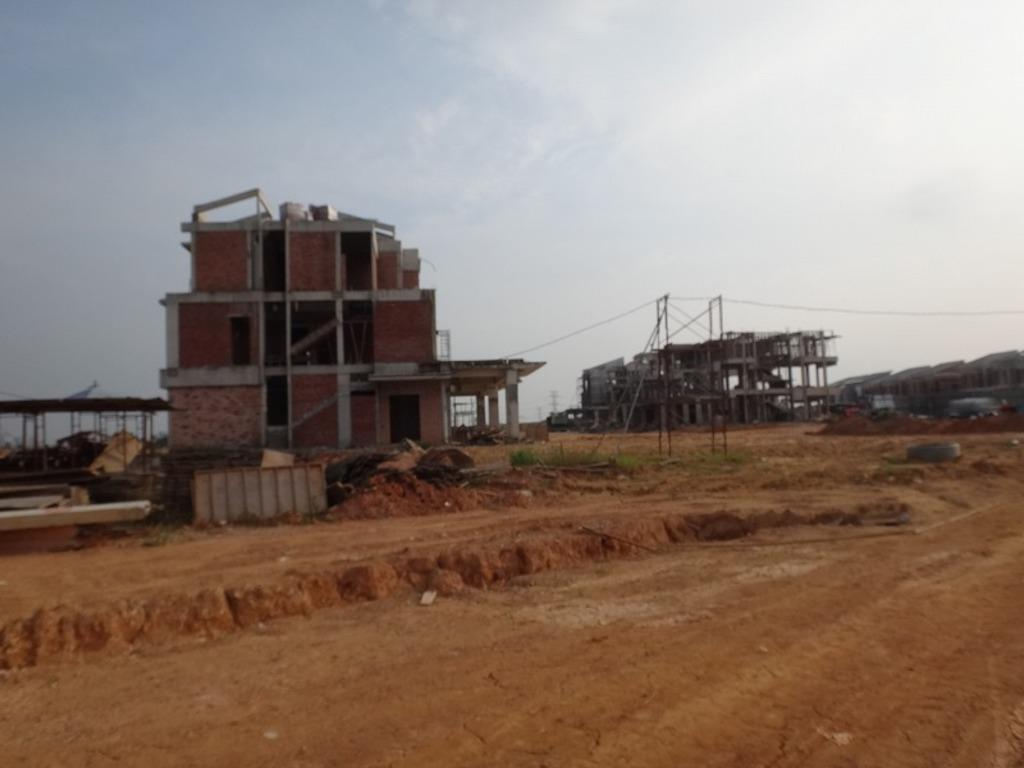What is the main subject of the image? The main subject of the image is under construction buildings. What else can be seen in the image besides the buildings? There are vehicles, trees, grass, poles, cables, a road, and clouds in the sky visible in the image. Can you describe the vehicles in the image? The vehicles in the image are not specified, but they are present. What type of vegetation is visible in the image? Trees and grass are visible in the image. What are the poles and cables used for in the image? The poles and cables are likely used for electrical or communication purposes. What is the condition of the sky in the image? The sky in the image has clouds visible. What type of leather is being used to construct the buildings in the image? There is no leather present in the image; the buildings are under construction using traditional building materials. 